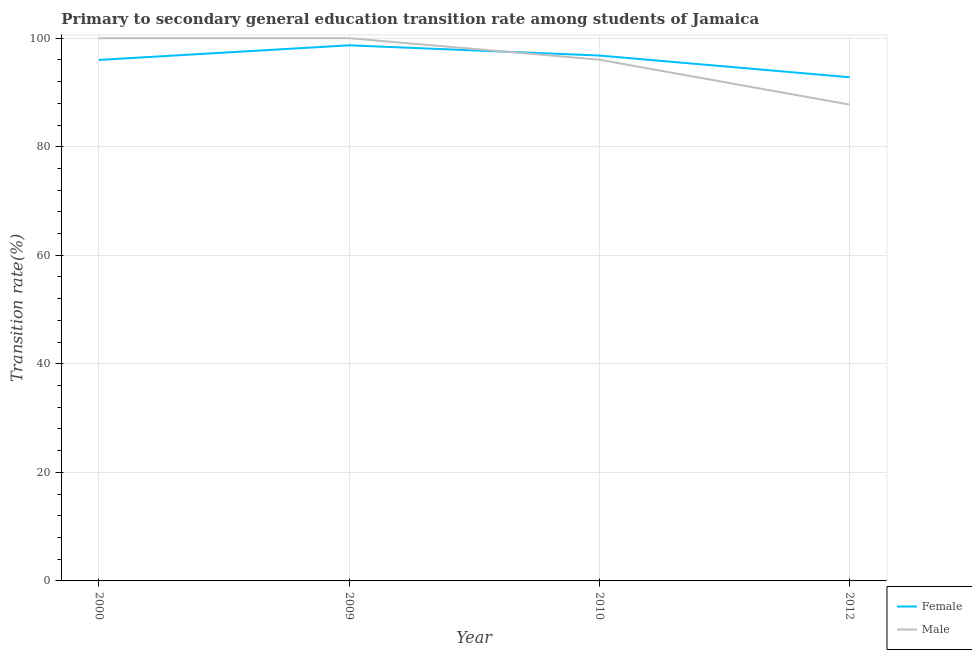How many different coloured lines are there?
Offer a very short reply. 2. Is the number of lines equal to the number of legend labels?
Provide a short and direct response. Yes. Across all years, what is the maximum transition rate among female students?
Offer a very short reply. 98.69. Across all years, what is the minimum transition rate among male students?
Make the answer very short. 87.77. In which year was the transition rate among male students maximum?
Make the answer very short. 2000. In which year was the transition rate among female students minimum?
Your answer should be compact. 2012. What is the total transition rate among female students in the graph?
Offer a very short reply. 384.3. What is the difference between the transition rate among female students in 2010 and that in 2012?
Provide a succinct answer. 4. What is the difference between the transition rate among female students in 2012 and the transition rate among male students in 2000?
Your answer should be very brief. -7.19. What is the average transition rate among female students per year?
Your response must be concise. 96.07. In the year 2012, what is the difference between the transition rate among female students and transition rate among male students?
Provide a short and direct response. 5.04. In how many years, is the transition rate among female students greater than 4 %?
Make the answer very short. 4. What is the difference between the highest and the second highest transition rate among female students?
Your answer should be very brief. 1.88. What is the difference between the highest and the lowest transition rate among male students?
Provide a short and direct response. 12.23. Does the transition rate among male students monotonically increase over the years?
Your answer should be very brief. No. Is the transition rate among female students strictly greater than the transition rate among male students over the years?
Provide a succinct answer. No. Is the transition rate among female students strictly less than the transition rate among male students over the years?
Keep it short and to the point. No. How many lines are there?
Offer a terse response. 2. How many years are there in the graph?
Provide a succinct answer. 4. Where does the legend appear in the graph?
Make the answer very short. Bottom right. What is the title of the graph?
Offer a very short reply. Primary to secondary general education transition rate among students of Jamaica. Does "Subsidies" appear as one of the legend labels in the graph?
Your response must be concise. No. What is the label or title of the Y-axis?
Ensure brevity in your answer.  Transition rate(%). What is the Transition rate(%) in Female in 2000?
Provide a short and direct response. 96. What is the Transition rate(%) of Female in 2009?
Your answer should be compact. 98.69. What is the Transition rate(%) in Female in 2010?
Provide a short and direct response. 96.81. What is the Transition rate(%) in Male in 2010?
Provide a short and direct response. 96.04. What is the Transition rate(%) in Female in 2012?
Your response must be concise. 92.81. What is the Transition rate(%) of Male in 2012?
Your response must be concise. 87.77. Across all years, what is the maximum Transition rate(%) of Female?
Offer a very short reply. 98.69. Across all years, what is the maximum Transition rate(%) of Male?
Ensure brevity in your answer.  100. Across all years, what is the minimum Transition rate(%) in Female?
Your response must be concise. 92.81. Across all years, what is the minimum Transition rate(%) of Male?
Your answer should be compact. 87.77. What is the total Transition rate(%) in Female in the graph?
Offer a terse response. 384.3. What is the total Transition rate(%) in Male in the graph?
Your response must be concise. 383.81. What is the difference between the Transition rate(%) in Female in 2000 and that in 2009?
Your response must be concise. -2.69. What is the difference between the Transition rate(%) of Female in 2000 and that in 2010?
Your answer should be very brief. -0.81. What is the difference between the Transition rate(%) in Male in 2000 and that in 2010?
Offer a terse response. 3.96. What is the difference between the Transition rate(%) of Female in 2000 and that in 2012?
Your answer should be very brief. 3.19. What is the difference between the Transition rate(%) in Male in 2000 and that in 2012?
Your response must be concise. 12.23. What is the difference between the Transition rate(%) of Female in 2009 and that in 2010?
Give a very brief answer. 1.88. What is the difference between the Transition rate(%) in Male in 2009 and that in 2010?
Your answer should be very brief. 3.96. What is the difference between the Transition rate(%) of Female in 2009 and that in 2012?
Provide a short and direct response. 5.88. What is the difference between the Transition rate(%) of Male in 2009 and that in 2012?
Keep it short and to the point. 12.23. What is the difference between the Transition rate(%) in Female in 2010 and that in 2012?
Provide a succinct answer. 4. What is the difference between the Transition rate(%) in Male in 2010 and that in 2012?
Offer a terse response. 8.27. What is the difference between the Transition rate(%) in Female in 2000 and the Transition rate(%) in Male in 2009?
Offer a terse response. -4. What is the difference between the Transition rate(%) of Female in 2000 and the Transition rate(%) of Male in 2010?
Ensure brevity in your answer.  -0.04. What is the difference between the Transition rate(%) in Female in 2000 and the Transition rate(%) in Male in 2012?
Your answer should be compact. 8.23. What is the difference between the Transition rate(%) of Female in 2009 and the Transition rate(%) of Male in 2010?
Your answer should be compact. 2.65. What is the difference between the Transition rate(%) of Female in 2009 and the Transition rate(%) of Male in 2012?
Give a very brief answer. 10.92. What is the difference between the Transition rate(%) in Female in 2010 and the Transition rate(%) in Male in 2012?
Provide a succinct answer. 9.04. What is the average Transition rate(%) of Female per year?
Your answer should be compact. 96.07. What is the average Transition rate(%) of Male per year?
Offer a terse response. 95.95. In the year 2000, what is the difference between the Transition rate(%) of Female and Transition rate(%) of Male?
Provide a succinct answer. -4. In the year 2009, what is the difference between the Transition rate(%) in Female and Transition rate(%) in Male?
Your response must be concise. -1.31. In the year 2010, what is the difference between the Transition rate(%) of Female and Transition rate(%) of Male?
Your response must be concise. 0.77. In the year 2012, what is the difference between the Transition rate(%) in Female and Transition rate(%) in Male?
Offer a very short reply. 5.04. What is the ratio of the Transition rate(%) of Female in 2000 to that in 2009?
Make the answer very short. 0.97. What is the ratio of the Transition rate(%) in Male in 2000 to that in 2009?
Your answer should be compact. 1. What is the ratio of the Transition rate(%) of Male in 2000 to that in 2010?
Your answer should be very brief. 1.04. What is the ratio of the Transition rate(%) of Female in 2000 to that in 2012?
Your answer should be compact. 1.03. What is the ratio of the Transition rate(%) in Male in 2000 to that in 2012?
Your answer should be very brief. 1.14. What is the ratio of the Transition rate(%) of Female in 2009 to that in 2010?
Make the answer very short. 1.02. What is the ratio of the Transition rate(%) of Male in 2009 to that in 2010?
Offer a terse response. 1.04. What is the ratio of the Transition rate(%) in Female in 2009 to that in 2012?
Provide a succinct answer. 1.06. What is the ratio of the Transition rate(%) of Male in 2009 to that in 2012?
Ensure brevity in your answer.  1.14. What is the ratio of the Transition rate(%) of Female in 2010 to that in 2012?
Keep it short and to the point. 1.04. What is the ratio of the Transition rate(%) in Male in 2010 to that in 2012?
Offer a very short reply. 1.09. What is the difference between the highest and the second highest Transition rate(%) in Female?
Your answer should be compact. 1.88. What is the difference between the highest and the lowest Transition rate(%) in Female?
Your response must be concise. 5.88. What is the difference between the highest and the lowest Transition rate(%) in Male?
Ensure brevity in your answer.  12.23. 